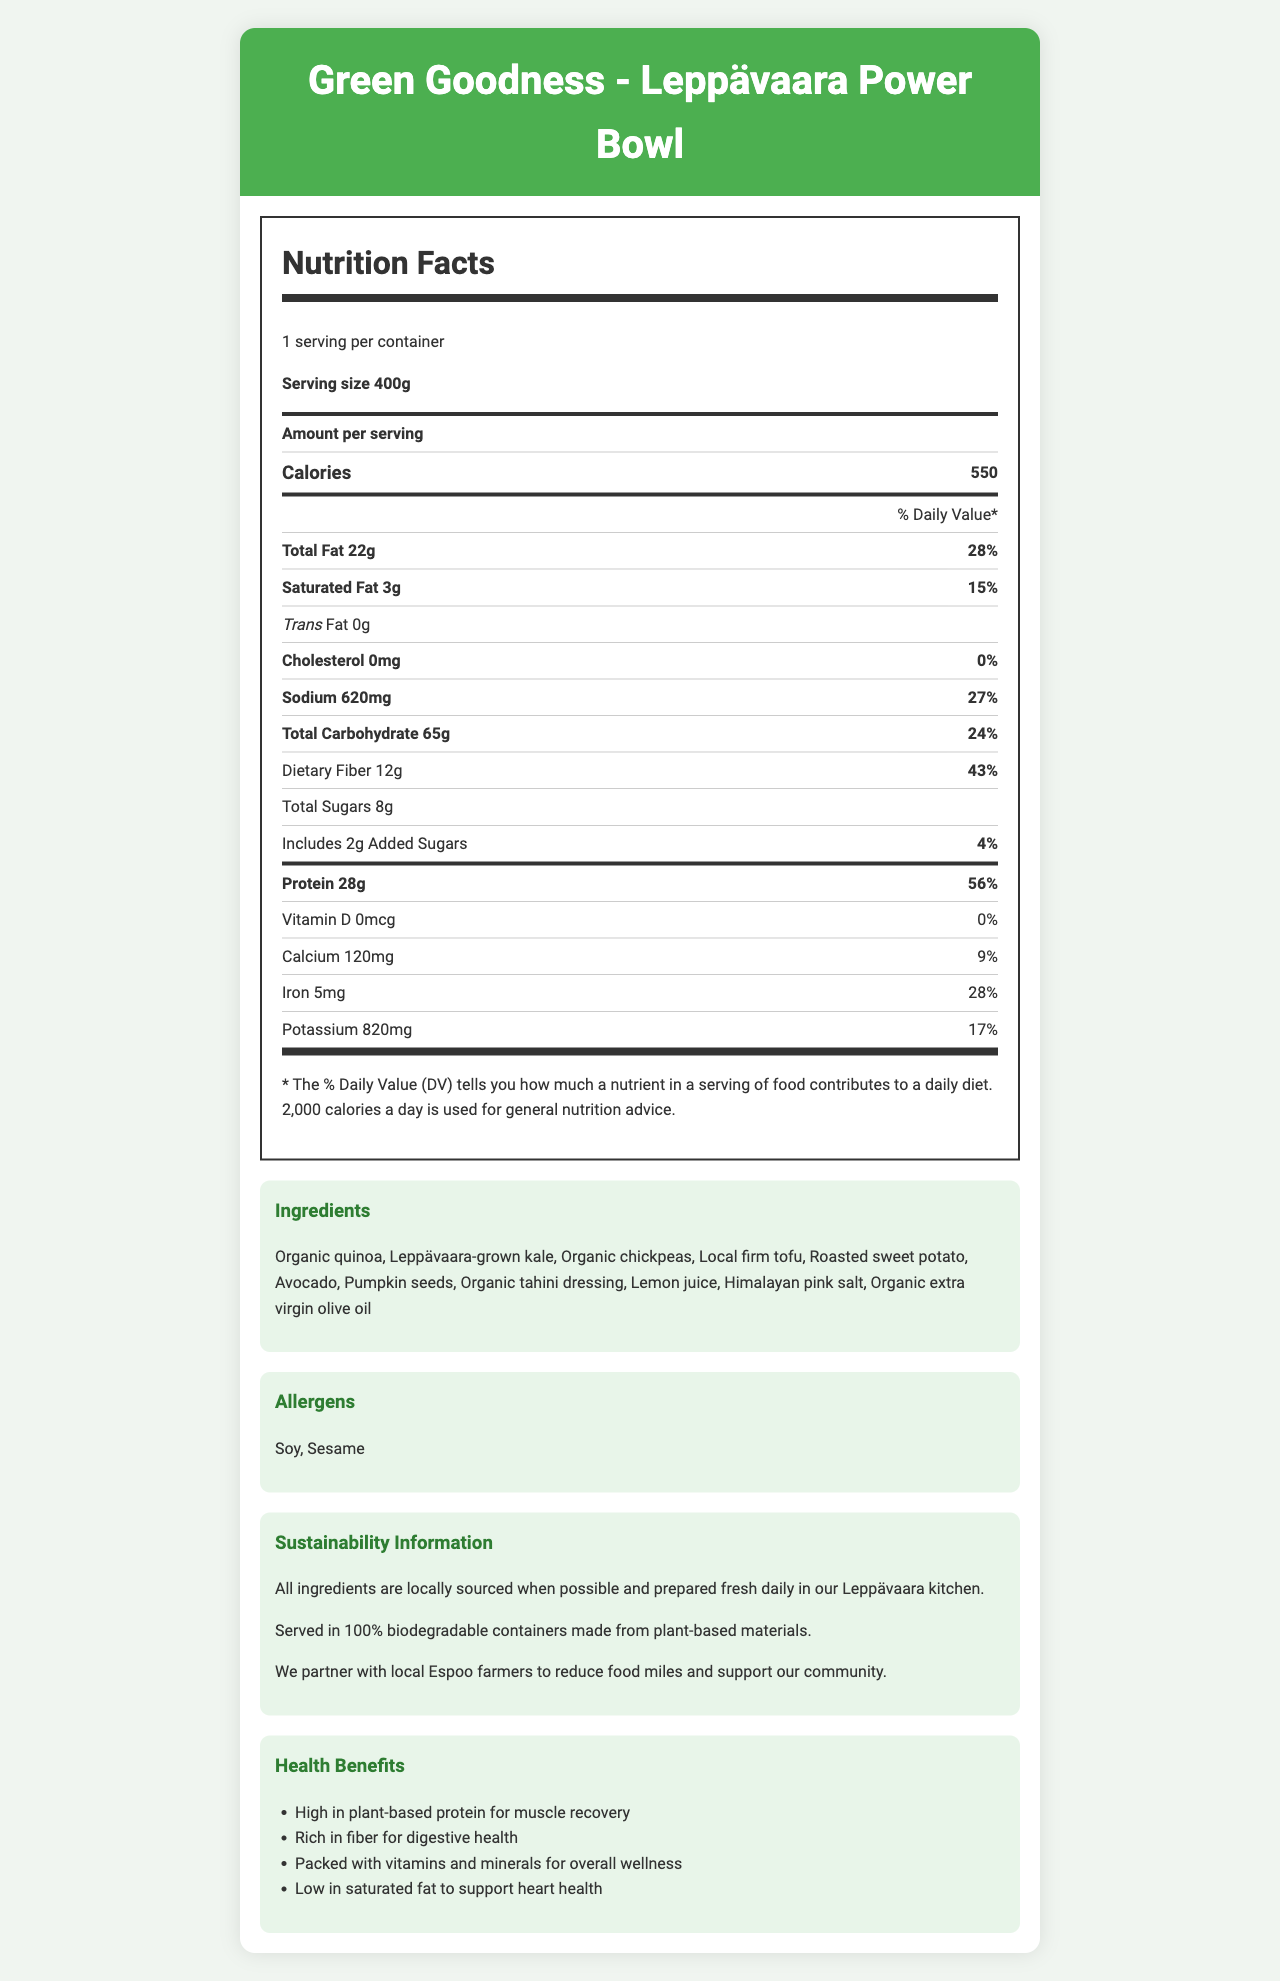What is the serving size of the Leppävaara Power Bowl? The serving size is clearly listed as 400g.
Answer: 400g How many calories are there per serving of the Leppävaara Power Bowl? The nutrition label indicates that there are 550 calories per serving.
Answer: 550 What percentage of the daily value for protein does the Leppävaara Power Bowl provide? The document states that the meal provides 28g of protein, which is 56% of the daily value.
Answer: 56% What are the main ingredients in the Leppävaara Power Bowl? The ingredient list provides these details.
Answer: Organic quinoa, Leppävaara-grown kale, Organic chickpeas, Local firm tofu, Roasted sweet potato, Avocado, Pumpkin seeds, Organic tahini dressing, Lemon juice, Himalayan pink salt, Organic extra virgin olive oil How much iron does the Leppävaara Power Bowl contain? The nutrition label states that the meal includes 5mg of iron.
Answer: 5mg Which of the following statements is true regarding the fat content of the Leppävaara Power Bowl? A. It has 10g of total fat B. It contains 0g of trans fat C. It has 10% daily value of saturated fat The document specifies a total fat of 22g, including 3g of saturated fat (15% DV), and explicitly mentions 0g of trans fat.
Answer: B. It contains 0g of trans fat What allergens are present in the Leppävaara Power Bowl? A. Dairy and nuts B. Soy and sesame C. Gluten and dairy The allergens listed are soy and sesame.
Answer: B. Soy and sesame How many grams of dietary fiber are in one serving? The nutrition label shows 12g of dietary fiber per serving.
Answer: 12g Is the packaging of the Leppävaara Power Bowl eco-friendly? The document mentions that the meal is served in 100% biodegradable containers made from plant-based materials.
Answer: Yes Describe the main nutritional benefits of the Leppävaara Power Bowl. The health benefits section highlights its high protein content (for muscle recovery), dietary fiber (for digestive health), presence of vitamins and minerals (for overall wellness), and low saturated fat (to support heart health).
Answer: High in plant-based protein, rich in fiber, packed with vitamins and minerals, low in saturated fat What is the preparation method of the Leppävaara Power Bowl? The document mentions the preparation process is done fresh locally, but further specific details about the method are not provided.
Answer: Cannot be determined How much sodium does one serving of the Leppävaara Power Bowl contain? The nutrition label lists the sodium content as 620mg per serving.
Answer: 620mg 